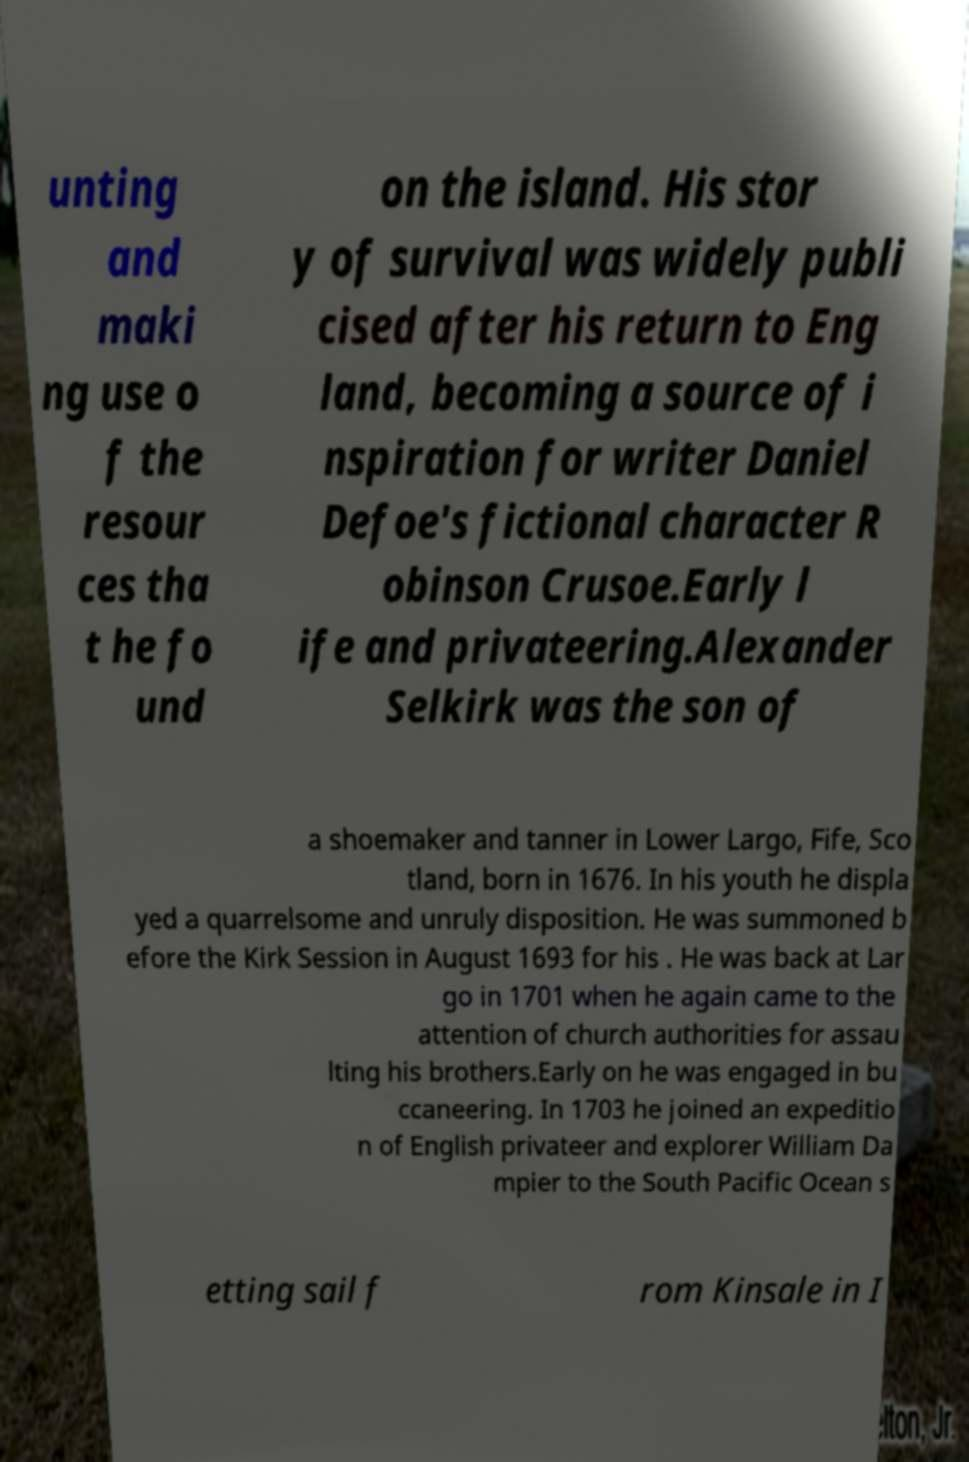Please identify and transcribe the text found in this image. unting and maki ng use o f the resour ces tha t he fo und on the island. His stor y of survival was widely publi cised after his return to Eng land, becoming a source of i nspiration for writer Daniel Defoe's fictional character R obinson Crusoe.Early l ife and privateering.Alexander Selkirk was the son of a shoemaker and tanner in Lower Largo, Fife, Sco tland, born in 1676. In his youth he displa yed a quarrelsome and unruly disposition. He was summoned b efore the Kirk Session in August 1693 for his . He was back at Lar go in 1701 when he again came to the attention of church authorities for assau lting his brothers.Early on he was engaged in bu ccaneering. In 1703 he joined an expeditio n of English privateer and explorer William Da mpier to the South Pacific Ocean s etting sail f rom Kinsale in I 